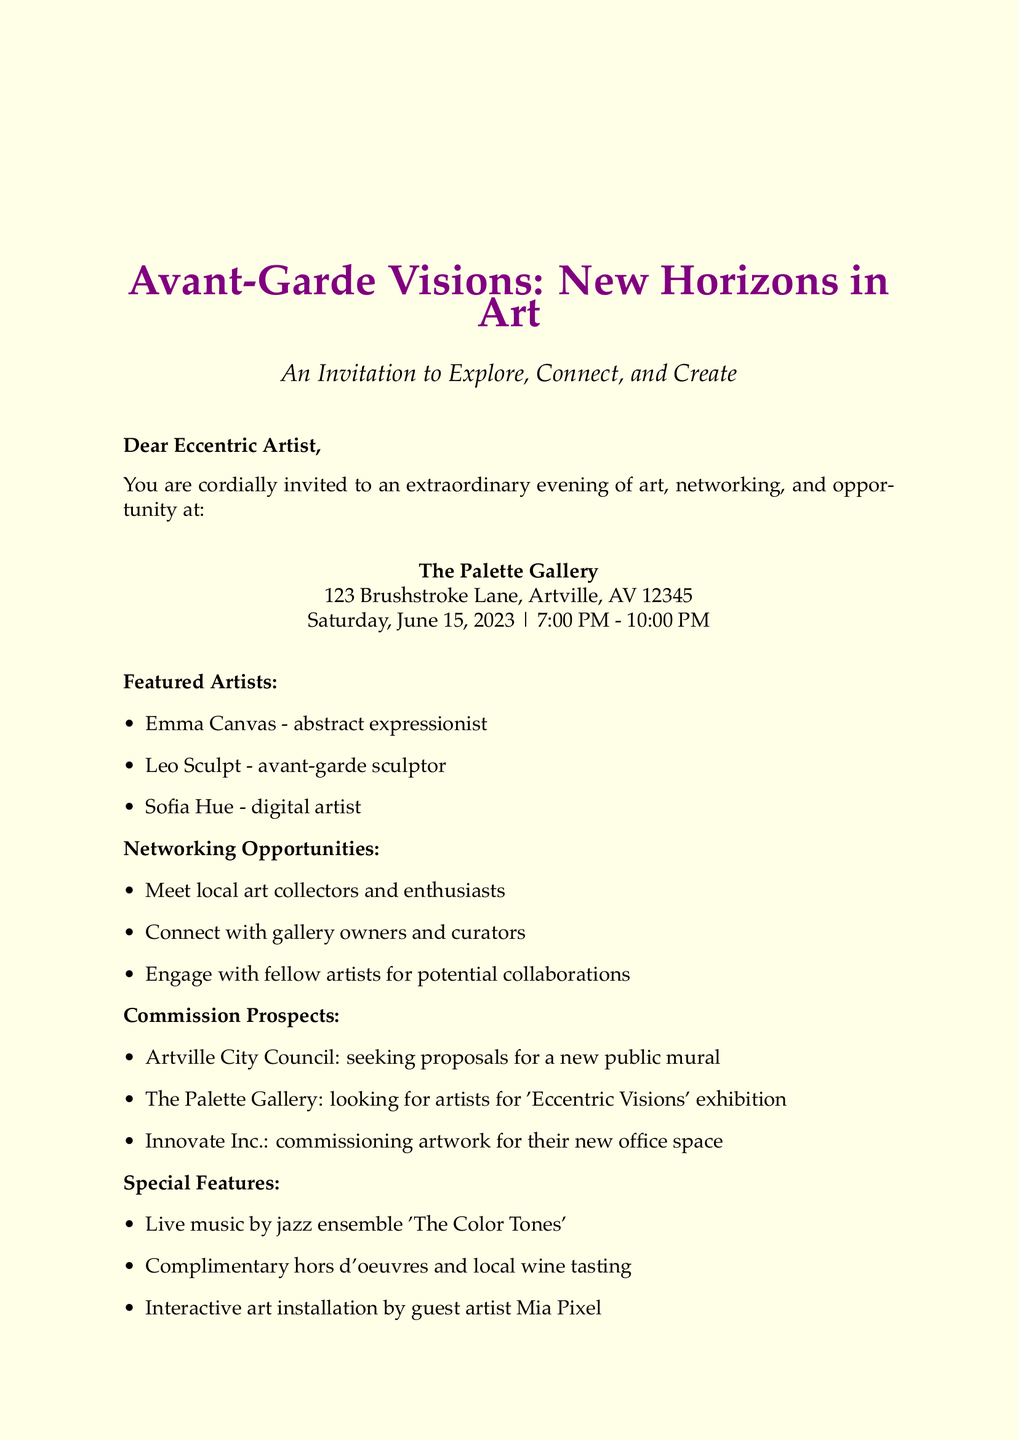What is the event name? The event name is clearly stated at the top of the document as "Avant-Garde Visions: New Horizons in Art."
Answer: Avant-Garde Visions: New Horizons in Art What is the venue for the event? The venue is explicitly mentioned in the address section of the document as "The Palette Gallery."
Answer: The Palette Gallery Who are the featured artists? The document lists three artists, which can be identified in the featured artists section.
Answer: Emma Canvas, Leo Sculpt, Sofia Hue What date is the event taking place? The date is specified in the event details section of the document as "Saturday, June 15, 2023."
Answer: Saturday, June 15, 2023 What networking opportunities are available? The document outlines several networking opportunities, requiring the reader to refer to that section.
Answer: Meet local art collectors and enthusiasts, Connect with gallery owners and curators, Engage with fellow artists for potential collaborations When is the RSVP deadline? The RSVP deadline is indicated towards the end of the document, making it easy to locate.
Answer: June 10, 2023 What special feature is included at the event? The document highlights special features of the event, where live music by 'The Color Tones' is mentioned.
Answer: Live music by jazz ensemble 'The Color Tones' What type of commissions are mentioned? The document lists several commission prospects, requiring synthesis of the information presented in that section.
Answer: Artville City Council, The Palette Gallery, Innovate Inc 